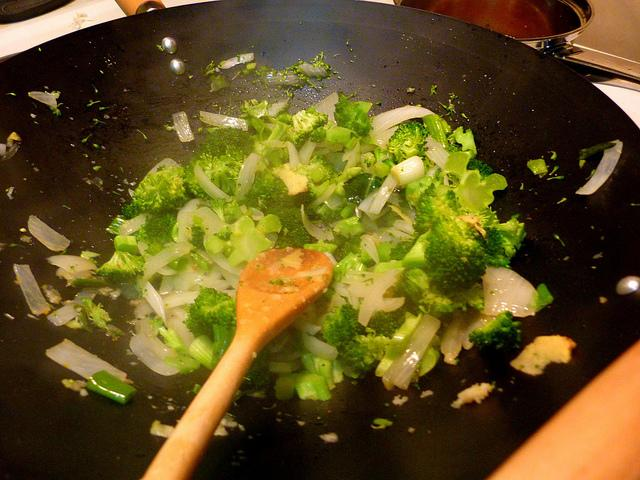What food type is in the pan?

Choices:
A) fruit
B) meat
C) vegetables
D) candy vegetables 